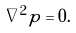Convert formula to latex. <formula><loc_0><loc_0><loc_500><loc_500>\nabla ^ { 2 } p = 0 .</formula> 